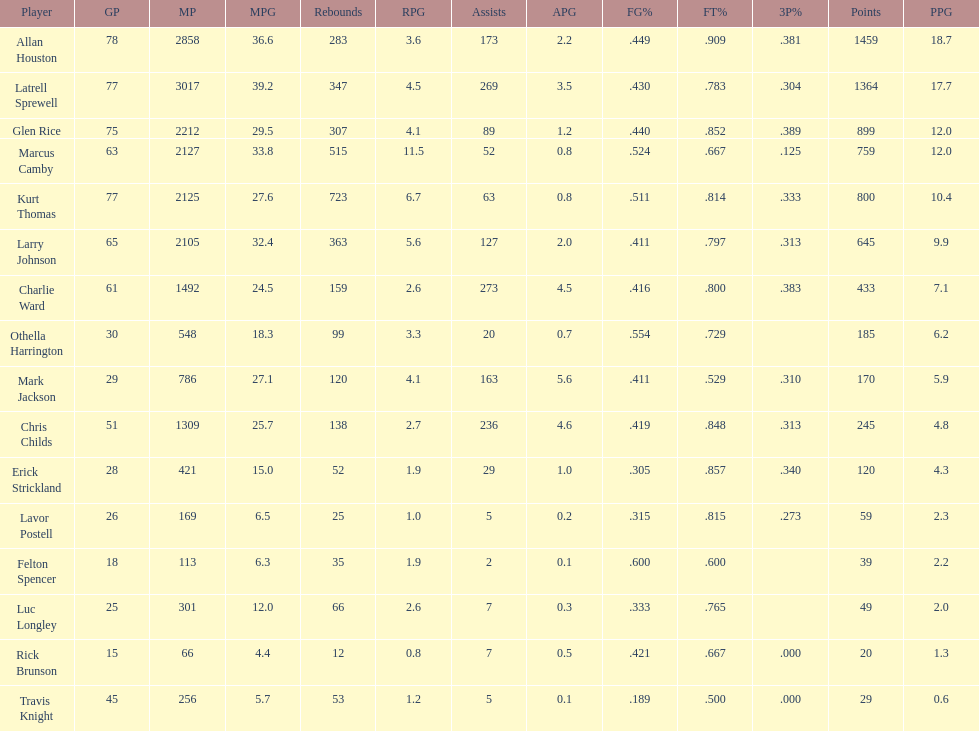How many games did larry johnson play? 65. 